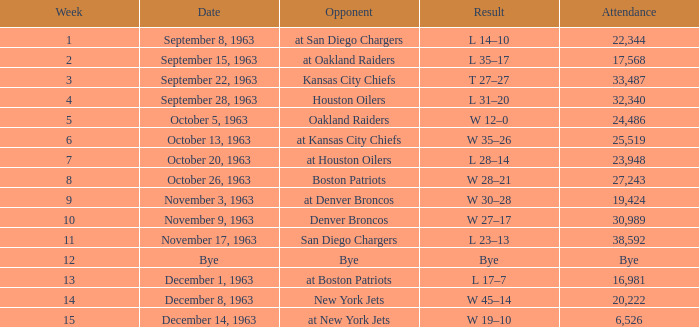Which Result has a Week smaller than 11, and Attendance of 17,568? L 35–17. 